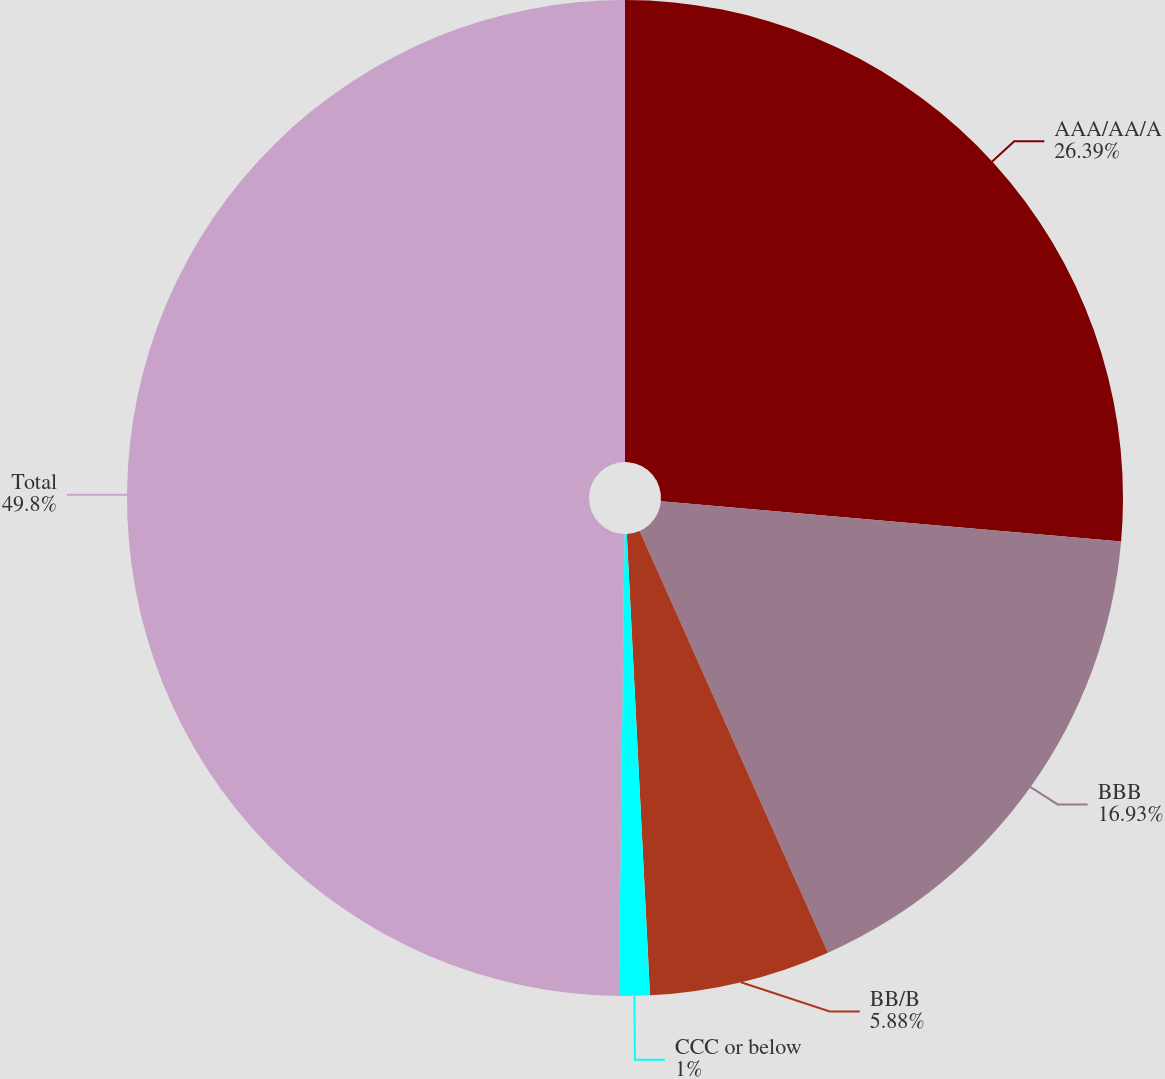Convert chart. <chart><loc_0><loc_0><loc_500><loc_500><pie_chart><fcel>AAA/AA/A<fcel>BBB<fcel>BB/B<fcel>CCC or below<fcel>Total<nl><fcel>26.39%<fcel>16.93%<fcel>5.88%<fcel>1.0%<fcel>49.8%<nl></chart> 